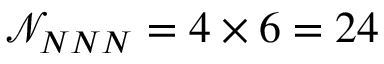Convert formula to latex. <formula><loc_0><loc_0><loc_500><loc_500>\mathcal { N } _ { N N N } = 4 \times 6 = 2 4</formula> 